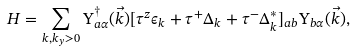Convert formula to latex. <formula><loc_0><loc_0><loc_500><loc_500>H = \sum _ { k , k _ { y } > 0 } \Upsilon ^ { \dagger } _ { a \alpha } ( \vec { k } ) [ \tau ^ { z } \epsilon _ { k } + \tau ^ { + } \Delta _ { k } + \tau ^ { - } \Delta ^ { * } _ { k } ] _ { a b } \Upsilon _ { b \alpha } ( \vec { k } ) ,</formula> 